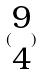Convert formula to latex. <formula><loc_0><loc_0><loc_500><loc_500>( \begin{matrix} 9 \\ 4 \end{matrix} )</formula> 